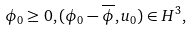Convert formula to latex. <formula><loc_0><loc_0><loc_500><loc_500>& \phi _ { 0 } \geq 0 , ( \phi _ { 0 } - \overline { \phi } , u _ { 0 } ) \in H ^ { 3 } ,</formula> 